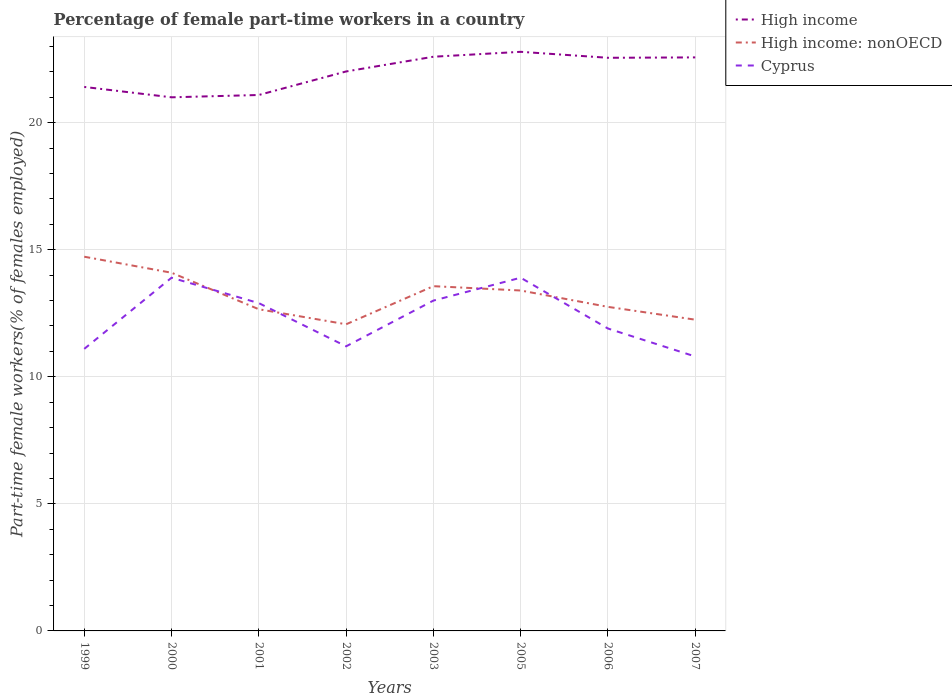Does the line corresponding to Cyprus intersect with the line corresponding to High income: nonOECD?
Your response must be concise. Yes. Across all years, what is the maximum percentage of female part-time workers in Cyprus?
Keep it short and to the point. 10.8. In which year was the percentage of female part-time workers in High income maximum?
Offer a terse response. 2000. What is the total percentage of female part-time workers in Cyprus in the graph?
Make the answer very short. -2.8. What is the difference between the highest and the second highest percentage of female part-time workers in High income?
Make the answer very short. 1.79. What is the difference between the highest and the lowest percentage of female part-time workers in Cyprus?
Keep it short and to the point. 4. Is the percentage of female part-time workers in High income strictly greater than the percentage of female part-time workers in Cyprus over the years?
Offer a terse response. No. How many lines are there?
Ensure brevity in your answer.  3. What is the difference between two consecutive major ticks on the Y-axis?
Provide a succinct answer. 5. Does the graph contain grids?
Your response must be concise. Yes. Where does the legend appear in the graph?
Your answer should be compact. Top right. How many legend labels are there?
Provide a short and direct response. 3. How are the legend labels stacked?
Make the answer very short. Vertical. What is the title of the graph?
Keep it short and to the point. Percentage of female part-time workers in a country. Does "Costa Rica" appear as one of the legend labels in the graph?
Offer a terse response. No. What is the label or title of the X-axis?
Offer a very short reply. Years. What is the label or title of the Y-axis?
Ensure brevity in your answer.  Part-time female workers(% of females employed). What is the Part-time female workers(% of females employed) of High income in 1999?
Provide a short and direct response. 21.41. What is the Part-time female workers(% of females employed) of High income: nonOECD in 1999?
Give a very brief answer. 14.73. What is the Part-time female workers(% of females employed) in Cyprus in 1999?
Your answer should be very brief. 11.1. What is the Part-time female workers(% of females employed) in High income in 2000?
Your answer should be compact. 21. What is the Part-time female workers(% of females employed) of High income: nonOECD in 2000?
Your answer should be very brief. 14.1. What is the Part-time female workers(% of females employed) of Cyprus in 2000?
Your response must be concise. 13.9. What is the Part-time female workers(% of females employed) of High income in 2001?
Offer a terse response. 21.09. What is the Part-time female workers(% of females employed) of High income: nonOECD in 2001?
Offer a terse response. 12.66. What is the Part-time female workers(% of females employed) of Cyprus in 2001?
Offer a terse response. 12.9. What is the Part-time female workers(% of females employed) of High income in 2002?
Offer a terse response. 22.02. What is the Part-time female workers(% of females employed) in High income: nonOECD in 2002?
Your answer should be compact. 12.07. What is the Part-time female workers(% of females employed) in Cyprus in 2002?
Provide a short and direct response. 11.2. What is the Part-time female workers(% of females employed) of High income in 2003?
Your answer should be compact. 22.6. What is the Part-time female workers(% of females employed) in High income: nonOECD in 2003?
Your answer should be very brief. 13.57. What is the Part-time female workers(% of females employed) in High income in 2005?
Provide a succinct answer. 22.79. What is the Part-time female workers(% of females employed) in High income: nonOECD in 2005?
Provide a succinct answer. 13.4. What is the Part-time female workers(% of females employed) in Cyprus in 2005?
Provide a succinct answer. 13.9. What is the Part-time female workers(% of females employed) in High income in 2006?
Offer a terse response. 22.55. What is the Part-time female workers(% of females employed) of High income: nonOECD in 2006?
Provide a short and direct response. 12.75. What is the Part-time female workers(% of females employed) of Cyprus in 2006?
Keep it short and to the point. 11.9. What is the Part-time female workers(% of females employed) in High income in 2007?
Provide a short and direct response. 22.57. What is the Part-time female workers(% of females employed) in High income: nonOECD in 2007?
Your response must be concise. 12.25. What is the Part-time female workers(% of females employed) of Cyprus in 2007?
Your response must be concise. 10.8. Across all years, what is the maximum Part-time female workers(% of females employed) in High income?
Give a very brief answer. 22.79. Across all years, what is the maximum Part-time female workers(% of females employed) of High income: nonOECD?
Keep it short and to the point. 14.73. Across all years, what is the maximum Part-time female workers(% of females employed) of Cyprus?
Offer a terse response. 13.9. Across all years, what is the minimum Part-time female workers(% of females employed) in High income?
Your answer should be compact. 21. Across all years, what is the minimum Part-time female workers(% of females employed) of High income: nonOECD?
Offer a terse response. 12.07. Across all years, what is the minimum Part-time female workers(% of females employed) in Cyprus?
Give a very brief answer. 10.8. What is the total Part-time female workers(% of females employed) of High income in the graph?
Ensure brevity in your answer.  176.03. What is the total Part-time female workers(% of females employed) in High income: nonOECD in the graph?
Your answer should be compact. 105.51. What is the total Part-time female workers(% of females employed) in Cyprus in the graph?
Offer a terse response. 98.7. What is the difference between the Part-time female workers(% of females employed) in High income in 1999 and that in 2000?
Provide a succinct answer. 0.41. What is the difference between the Part-time female workers(% of females employed) in High income: nonOECD in 1999 and that in 2000?
Offer a terse response. 0.63. What is the difference between the Part-time female workers(% of females employed) in Cyprus in 1999 and that in 2000?
Your answer should be very brief. -2.8. What is the difference between the Part-time female workers(% of females employed) in High income in 1999 and that in 2001?
Your answer should be compact. 0.32. What is the difference between the Part-time female workers(% of females employed) of High income: nonOECD in 1999 and that in 2001?
Provide a short and direct response. 2.07. What is the difference between the Part-time female workers(% of females employed) in High income in 1999 and that in 2002?
Keep it short and to the point. -0.61. What is the difference between the Part-time female workers(% of females employed) in High income: nonOECD in 1999 and that in 2002?
Give a very brief answer. 2.66. What is the difference between the Part-time female workers(% of females employed) in High income in 1999 and that in 2003?
Your answer should be very brief. -1.19. What is the difference between the Part-time female workers(% of females employed) in High income: nonOECD in 1999 and that in 2003?
Your answer should be compact. 1.16. What is the difference between the Part-time female workers(% of females employed) in High income in 1999 and that in 2005?
Your answer should be very brief. -1.38. What is the difference between the Part-time female workers(% of females employed) of High income: nonOECD in 1999 and that in 2005?
Give a very brief answer. 1.33. What is the difference between the Part-time female workers(% of females employed) of High income in 1999 and that in 2006?
Offer a terse response. -1.15. What is the difference between the Part-time female workers(% of females employed) of High income: nonOECD in 1999 and that in 2006?
Keep it short and to the point. 1.97. What is the difference between the Part-time female workers(% of females employed) of Cyprus in 1999 and that in 2006?
Give a very brief answer. -0.8. What is the difference between the Part-time female workers(% of females employed) of High income in 1999 and that in 2007?
Ensure brevity in your answer.  -1.16. What is the difference between the Part-time female workers(% of females employed) in High income: nonOECD in 1999 and that in 2007?
Your response must be concise. 2.48. What is the difference between the Part-time female workers(% of females employed) in High income in 2000 and that in 2001?
Your answer should be compact. -0.09. What is the difference between the Part-time female workers(% of females employed) in High income: nonOECD in 2000 and that in 2001?
Keep it short and to the point. 1.44. What is the difference between the Part-time female workers(% of females employed) in High income in 2000 and that in 2002?
Make the answer very short. -1.02. What is the difference between the Part-time female workers(% of females employed) in High income: nonOECD in 2000 and that in 2002?
Your response must be concise. 2.03. What is the difference between the Part-time female workers(% of females employed) in High income in 2000 and that in 2003?
Make the answer very short. -1.6. What is the difference between the Part-time female workers(% of females employed) of High income: nonOECD in 2000 and that in 2003?
Offer a terse response. 0.53. What is the difference between the Part-time female workers(% of females employed) of High income in 2000 and that in 2005?
Your answer should be very brief. -1.79. What is the difference between the Part-time female workers(% of females employed) of High income: nonOECD in 2000 and that in 2005?
Your response must be concise. 0.7. What is the difference between the Part-time female workers(% of females employed) of Cyprus in 2000 and that in 2005?
Make the answer very short. 0. What is the difference between the Part-time female workers(% of females employed) in High income in 2000 and that in 2006?
Offer a very short reply. -1.56. What is the difference between the Part-time female workers(% of females employed) in High income: nonOECD in 2000 and that in 2006?
Make the answer very short. 1.34. What is the difference between the Part-time female workers(% of females employed) of High income in 2000 and that in 2007?
Keep it short and to the point. -1.57. What is the difference between the Part-time female workers(% of females employed) in High income: nonOECD in 2000 and that in 2007?
Your answer should be compact. 1.85. What is the difference between the Part-time female workers(% of females employed) in High income in 2001 and that in 2002?
Provide a succinct answer. -0.93. What is the difference between the Part-time female workers(% of females employed) in High income: nonOECD in 2001 and that in 2002?
Offer a terse response. 0.59. What is the difference between the Part-time female workers(% of females employed) in High income in 2001 and that in 2003?
Ensure brevity in your answer.  -1.51. What is the difference between the Part-time female workers(% of females employed) in High income: nonOECD in 2001 and that in 2003?
Offer a terse response. -0.91. What is the difference between the Part-time female workers(% of females employed) of Cyprus in 2001 and that in 2003?
Make the answer very short. -0.1. What is the difference between the Part-time female workers(% of females employed) of High income in 2001 and that in 2005?
Offer a terse response. -1.7. What is the difference between the Part-time female workers(% of females employed) of High income: nonOECD in 2001 and that in 2005?
Make the answer very short. -0.74. What is the difference between the Part-time female workers(% of females employed) of Cyprus in 2001 and that in 2005?
Make the answer very short. -1. What is the difference between the Part-time female workers(% of females employed) in High income in 2001 and that in 2006?
Your answer should be very brief. -1.46. What is the difference between the Part-time female workers(% of females employed) of High income: nonOECD in 2001 and that in 2006?
Offer a very short reply. -0.09. What is the difference between the Part-time female workers(% of females employed) in High income in 2001 and that in 2007?
Your response must be concise. -1.48. What is the difference between the Part-time female workers(% of females employed) in High income: nonOECD in 2001 and that in 2007?
Provide a succinct answer. 0.41. What is the difference between the Part-time female workers(% of females employed) in High income in 2002 and that in 2003?
Your answer should be very brief. -0.58. What is the difference between the Part-time female workers(% of females employed) in High income: nonOECD in 2002 and that in 2003?
Your response must be concise. -1.5. What is the difference between the Part-time female workers(% of females employed) in Cyprus in 2002 and that in 2003?
Your answer should be compact. -1.8. What is the difference between the Part-time female workers(% of females employed) of High income in 2002 and that in 2005?
Make the answer very short. -0.77. What is the difference between the Part-time female workers(% of females employed) in High income: nonOECD in 2002 and that in 2005?
Your answer should be very brief. -1.33. What is the difference between the Part-time female workers(% of females employed) in High income in 2002 and that in 2006?
Make the answer very short. -0.54. What is the difference between the Part-time female workers(% of females employed) in High income: nonOECD in 2002 and that in 2006?
Give a very brief answer. -0.68. What is the difference between the Part-time female workers(% of females employed) in Cyprus in 2002 and that in 2006?
Provide a short and direct response. -0.7. What is the difference between the Part-time female workers(% of females employed) in High income in 2002 and that in 2007?
Offer a terse response. -0.55. What is the difference between the Part-time female workers(% of females employed) in High income: nonOECD in 2002 and that in 2007?
Provide a succinct answer. -0.18. What is the difference between the Part-time female workers(% of females employed) of High income in 2003 and that in 2005?
Provide a succinct answer. -0.19. What is the difference between the Part-time female workers(% of females employed) in High income: nonOECD in 2003 and that in 2005?
Offer a very short reply. 0.17. What is the difference between the Part-time female workers(% of females employed) of Cyprus in 2003 and that in 2005?
Offer a terse response. -0.9. What is the difference between the Part-time female workers(% of females employed) in High income in 2003 and that in 2006?
Provide a short and direct response. 0.04. What is the difference between the Part-time female workers(% of females employed) in High income: nonOECD in 2003 and that in 2006?
Your response must be concise. 0.81. What is the difference between the Part-time female workers(% of females employed) of High income in 2003 and that in 2007?
Provide a short and direct response. 0.03. What is the difference between the Part-time female workers(% of females employed) in High income: nonOECD in 2003 and that in 2007?
Give a very brief answer. 1.32. What is the difference between the Part-time female workers(% of females employed) in Cyprus in 2003 and that in 2007?
Provide a short and direct response. 2.2. What is the difference between the Part-time female workers(% of females employed) in High income in 2005 and that in 2006?
Offer a terse response. 0.24. What is the difference between the Part-time female workers(% of females employed) in High income: nonOECD in 2005 and that in 2006?
Offer a very short reply. 0.64. What is the difference between the Part-time female workers(% of females employed) of High income in 2005 and that in 2007?
Your answer should be very brief. 0.22. What is the difference between the Part-time female workers(% of females employed) in High income: nonOECD in 2005 and that in 2007?
Give a very brief answer. 1.15. What is the difference between the Part-time female workers(% of females employed) in High income in 2006 and that in 2007?
Offer a terse response. -0.02. What is the difference between the Part-time female workers(% of females employed) in High income: nonOECD in 2006 and that in 2007?
Offer a terse response. 0.5. What is the difference between the Part-time female workers(% of females employed) in High income in 1999 and the Part-time female workers(% of females employed) in High income: nonOECD in 2000?
Provide a short and direct response. 7.31. What is the difference between the Part-time female workers(% of females employed) in High income in 1999 and the Part-time female workers(% of females employed) in Cyprus in 2000?
Your response must be concise. 7.51. What is the difference between the Part-time female workers(% of females employed) of High income: nonOECD in 1999 and the Part-time female workers(% of females employed) of Cyprus in 2000?
Offer a very short reply. 0.83. What is the difference between the Part-time female workers(% of females employed) of High income in 1999 and the Part-time female workers(% of females employed) of High income: nonOECD in 2001?
Ensure brevity in your answer.  8.75. What is the difference between the Part-time female workers(% of females employed) of High income in 1999 and the Part-time female workers(% of females employed) of Cyprus in 2001?
Ensure brevity in your answer.  8.51. What is the difference between the Part-time female workers(% of females employed) of High income: nonOECD in 1999 and the Part-time female workers(% of females employed) of Cyprus in 2001?
Make the answer very short. 1.83. What is the difference between the Part-time female workers(% of females employed) of High income in 1999 and the Part-time female workers(% of females employed) of High income: nonOECD in 2002?
Provide a succinct answer. 9.34. What is the difference between the Part-time female workers(% of females employed) in High income in 1999 and the Part-time female workers(% of females employed) in Cyprus in 2002?
Your answer should be very brief. 10.21. What is the difference between the Part-time female workers(% of females employed) in High income: nonOECD in 1999 and the Part-time female workers(% of females employed) in Cyprus in 2002?
Your response must be concise. 3.53. What is the difference between the Part-time female workers(% of females employed) in High income in 1999 and the Part-time female workers(% of females employed) in High income: nonOECD in 2003?
Your response must be concise. 7.84. What is the difference between the Part-time female workers(% of females employed) in High income in 1999 and the Part-time female workers(% of females employed) in Cyprus in 2003?
Provide a short and direct response. 8.41. What is the difference between the Part-time female workers(% of females employed) in High income: nonOECD in 1999 and the Part-time female workers(% of females employed) in Cyprus in 2003?
Your response must be concise. 1.73. What is the difference between the Part-time female workers(% of females employed) of High income in 1999 and the Part-time female workers(% of females employed) of High income: nonOECD in 2005?
Make the answer very short. 8.01. What is the difference between the Part-time female workers(% of females employed) of High income in 1999 and the Part-time female workers(% of females employed) of Cyprus in 2005?
Your answer should be compact. 7.51. What is the difference between the Part-time female workers(% of females employed) in High income: nonOECD in 1999 and the Part-time female workers(% of females employed) in Cyprus in 2005?
Make the answer very short. 0.83. What is the difference between the Part-time female workers(% of females employed) of High income in 1999 and the Part-time female workers(% of females employed) of High income: nonOECD in 2006?
Keep it short and to the point. 8.66. What is the difference between the Part-time female workers(% of females employed) of High income in 1999 and the Part-time female workers(% of females employed) of Cyprus in 2006?
Your answer should be compact. 9.51. What is the difference between the Part-time female workers(% of females employed) of High income: nonOECD in 1999 and the Part-time female workers(% of females employed) of Cyprus in 2006?
Offer a very short reply. 2.83. What is the difference between the Part-time female workers(% of females employed) in High income in 1999 and the Part-time female workers(% of females employed) in High income: nonOECD in 2007?
Your answer should be compact. 9.16. What is the difference between the Part-time female workers(% of females employed) of High income in 1999 and the Part-time female workers(% of females employed) of Cyprus in 2007?
Give a very brief answer. 10.61. What is the difference between the Part-time female workers(% of females employed) of High income: nonOECD in 1999 and the Part-time female workers(% of females employed) of Cyprus in 2007?
Ensure brevity in your answer.  3.93. What is the difference between the Part-time female workers(% of females employed) of High income in 2000 and the Part-time female workers(% of females employed) of High income: nonOECD in 2001?
Keep it short and to the point. 8.34. What is the difference between the Part-time female workers(% of females employed) of High income in 2000 and the Part-time female workers(% of females employed) of Cyprus in 2001?
Provide a succinct answer. 8.1. What is the difference between the Part-time female workers(% of females employed) in High income: nonOECD in 2000 and the Part-time female workers(% of females employed) in Cyprus in 2001?
Ensure brevity in your answer.  1.2. What is the difference between the Part-time female workers(% of females employed) of High income in 2000 and the Part-time female workers(% of females employed) of High income: nonOECD in 2002?
Make the answer very short. 8.93. What is the difference between the Part-time female workers(% of females employed) of High income in 2000 and the Part-time female workers(% of females employed) of Cyprus in 2002?
Provide a short and direct response. 9.8. What is the difference between the Part-time female workers(% of females employed) in High income: nonOECD in 2000 and the Part-time female workers(% of females employed) in Cyprus in 2002?
Provide a short and direct response. 2.9. What is the difference between the Part-time female workers(% of females employed) in High income in 2000 and the Part-time female workers(% of females employed) in High income: nonOECD in 2003?
Make the answer very short. 7.43. What is the difference between the Part-time female workers(% of females employed) in High income in 2000 and the Part-time female workers(% of females employed) in Cyprus in 2003?
Your response must be concise. 8. What is the difference between the Part-time female workers(% of females employed) in High income: nonOECD in 2000 and the Part-time female workers(% of females employed) in Cyprus in 2003?
Provide a succinct answer. 1.1. What is the difference between the Part-time female workers(% of females employed) of High income in 2000 and the Part-time female workers(% of females employed) of High income: nonOECD in 2005?
Provide a succinct answer. 7.6. What is the difference between the Part-time female workers(% of females employed) in High income in 2000 and the Part-time female workers(% of females employed) in Cyprus in 2005?
Your answer should be compact. 7.1. What is the difference between the Part-time female workers(% of females employed) in High income: nonOECD in 2000 and the Part-time female workers(% of females employed) in Cyprus in 2005?
Make the answer very short. 0.2. What is the difference between the Part-time female workers(% of females employed) of High income in 2000 and the Part-time female workers(% of females employed) of High income: nonOECD in 2006?
Offer a terse response. 8.25. What is the difference between the Part-time female workers(% of females employed) in High income in 2000 and the Part-time female workers(% of females employed) in Cyprus in 2006?
Your response must be concise. 9.1. What is the difference between the Part-time female workers(% of females employed) in High income: nonOECD in 2000 and the Part-time female workers(% of females employed) in Cyprus in 2006?
Keep it short and to the point. 2.2. What is the difference between the Part-time female workers(% of females employed) in High income in 2000 and the Part-time female workers(% of females employed) in High income: nonOECD in 2007?
Your answer should be compact. 8.75. What is the difference between the Part-time female workers(% of females employed) in High income in 2000 and the Part-time female workers(% of females employed) in Cyprus in 2007?
Your answer should be compact. 10.2. What is the difference between the Part-time female workers(% of females employed) in High income: nonOECD in 2000 and the Part-time female workers(% of females employed) in Cyprus in 2007?
Make the answer very short. 3.3. What is the difference between the Part-time female workers(% of females employed) of High income in 2001 and the Part-time female workers(% of females employed) of High income: nonOECD in 2002?
Ensure brevity in your answer.  9.02. What is the difference between the Part-time female workers(% of females employed) in High income in 2001 and the Part-time female workers(% of females employed) in Cyprus in 2002?
Your answer should be compact. 9.89. What is the difference between the Part-time female workers(% of females employed) of High income: nonOECD in 2001 and the Part-time female workers(% of females employed) of Cyprus in 2002?
Keep it short and to the point. 1.46. What is the difference between the Part-time female workers(% of females employed) of High income in 2001 and the Part-time female workers(% of females employed) of High income: nonOECD in 2003?
Offer a terse response. 7.52. What is the difference between the Part-time female workers(% of females employed) of High income in 2001 and the Part-time female workers(% of females employed) of Cyprus in 2003?
Ensure brevity in your answer.  8.09. What is the difference between the Part-time female workers(% of females employed) in High income: nonOECD in 2001 and the Part-time female workers(% of females employed) in Cyprus in 2003?
Your response must be concise. -0.34. What is the difference between the Part-time female workers(% of females employed) in High income in 2001 and the Part-time female workers(% of females employed) in High income: nonOECD in 2005?
Your response must be concise. 7.69. What is the difference between the Part-time female workers(% of females employed) of High income in 2001 and the Part-time female workers(% of females employed) of Cyprus in 2005?
Make the answer very short. 7.19. What is the difference between the Part-time female workers(% of females employed) in High income: nonOECD in 2001 and the Part-time female workers(% of females employed) in Cyprus in 2005?
Ensure brevity in your answer.  -1.24. What is the difference between the Part-time female workers(% of females employed) in High income in 2001 and the Part-time female workers(% of females employed) in High income: nonOECD in 2006?
Ensure brevity in your answer.  8.34. What is the difference between the Part-time female workers(% of females employed) in High income in 2001 and the Part-time female workers(% of females employed) in Cyprus in 2006?
Offer a terse response. 9.19. What is the difference between the Part-time female workers(% of females employed) of High income: nonOECD in 2001 and the Part-time female workers(% of females employed) of Cyprus in 2006?
Ensure brevity in your answer.  0.76. What is the difference between the Part-time female workers(% of females employed) in High income in 2001 and the Part-time female workers(% of females employed) in High income: nonOECD in 2007?
Make the answer very short. 8.84. What is the difference between the Part-time female workers(% of females employed) of High income in 2001 and the Part-time female workers(% of females employed) of Cyprus in 2007?
Your answer should be very brief. 10.29. What is the difference between the Part-time female workers(% of females employed) in High income: nonOECD in 2001 and the Part-time female workers(% of females employed) in Cyprus in 2007?
Offer a very short reply. 1.86. What is the difference between the Part-time female workers(% of females employed) in High income in 2002 and the Part-time female workers(% of females employed) in High income: nonOECD in 2003?
Offer a terse response. 8.45. What is the difference between the Part-time female workers(% of females employed) in High income in 2002 and the Part-time female workers(% of females employed) in Cyprus in 2003?
Give a very brief answer. 9.02. What is the difference between the Part-time female workers(% of females employed) of High income: nonOECD in 2002 and the Part-time female workers(% of females employed) of Cyprus in 2003?
Give a very brief answer. -0.93. What is the difference between the Part-time female workers(% of females employed) in High income in 2002 and the Part-time female workers(% of females employed) in High income: nonOECD in 2005?
Offer a terse response. 8.62. What is the difference between the Part-time female workers(% of females employed) in High income in 2002 and the Part-time female workers(% of females employed) in Cyprus in 2005?
Your answer should be very brief. 8.12. What is the difference between the Part-time female workers(% of females employed) in High income: nonOECD in 2002 and the Part-time female workers(% of females employed) in Cyprus in 2005?
Make the answer very short. -1.83. What is the difference between the Part-time female workers(% of females employed) in High income in 2002 and the Part-time female workers(% of females employed) in High income: nonOECD in 2006?
Your answer should be very brief. 9.26. What is the difference between the Part-time female workers(% of females employed) in High income in 2002 and the Part-time female workers(% of females employed) in Cyprus in 2006?
Provide a succinct answer. 10.12. What is the difference between the Part-time female workers(% of females employed) of High income: nonOECD in 2002 and the Part-time female workers(% of females employed) of Cyprus in 2006?
Provide a succinct answer. 0.17. What is the difference between the Part-time female workers(% of females employed) in High income in 2002 and the Part-time female workers(% of females employed) in High income: nonOECD in 2007?
Ensure brevity in your answer.  9.77. What is the difference between the Part-time female workers(% of females employed) in High income in 2002 and the Part-time female workers(% of females employed) in Cyprus in 2007?
Provide a short and direct response. 11.22. What is the difference between the Part-time female workers(% of females employed) of High income: nonOECD in 2002 and the Part-time female workers(% of females employed) of Cyprus in 2007?
Your answer should be compact. 1.27. What is the difference between the Part-time female workers(% of females employed) in High income in 2003 and the Part-time female workers(% of females employed) in High income: nonOECD in 2005?
Offer a very short reply. 9.2. What is the difference between the Part-time female workers(% of females employed) in High income in 2003 and the Part-time female workers(% of females employed) in Cyprus in 2005?
Make the answer very short. 8.7. What is the difference between the Part-time female workers(% of females employed) of High income: nonOECD in 2003 and the Part-time female workers(% of females employed) of Cyprus in 2005?
Offer a very short reply. -0.33. What is the difference between the Part-time female workers(% of females employed) in High income in 2003 and the Part-time female workers(% of females employed) in High income: nonOECD in 2006?
Keep it short and to the point. 9.84. What is the difference between the Part-time female workers(% of females employed) in High income in 2003 and the Part-time female workers(% of females employed) in Cyprus in 2006?
Offer a terse response. 10.7. What is the difference between the Part-time female workers(% of females employed) of High income: nonOECD in 2003 and the Part-time female workers(% of females employed) of Cyprus in 2006?
Provide a succinct answer. 1.67. What is the difference between the Part-time female workers(% of females employed) of High income in 2003 and the Part-time female workers(% of females employed) of High income: nonOECD in 2007?
Your answer should be very brief. 10.35. What is the difference between the Part-time female workers(% of females employed) in High income in 2003 and the Part-time female workers(% of females employed) in Cyprus in 2007?
Ensure brevity in your answer.  11.8. What is the difference between the Part-time female workers(% of females employed) in High income: nonOECD in 2003 and the Part-time female workers(% of females employed) in Cyprus in 2007?
Your answer should be compact. 2.77. What is the difference between the Part-time female workers(% of females employed) of High income in 2005 and the Part-time female workers(% of females employed) of High income: nonOECD in 2006?
Provide a succinct answer. 10.04. What is the difference between the Part-time female workers(% of females employed) in High income in 2005 and the Part-time female workers(% of females employed) in Cyprus in 2006?
Offer a very short reply. 10.89. What is the difference between the Part-time female workers(% of females employed) in High income: nonOECD in 2005 and the Part-time female workers(% of females employed) in Cyprus in 2006?
Offer a terse response. 1.5. What is the difference between the Part-time female workers(% of females employed) of High income in 2005 and the Part-time female workers(% of females employed) of High income: nonOECD in 2007?
Give a very brief answer. 10.54. What is the difference between the Part-time female workers(% of females employed) in High income in 2005 and the Part-time female workers(% of females employed) in Cyprus in 2007?
Offer a very short reply. 11.99. What is the difference between the Part-time female workers(% of females employed) in High income: nonOECD in 2005 and the Part-time female workers(% of females employed) in Cyprus in 2007?
Offer a very short reply. 2.6. What is the difference between the Part-time female workers(% of females employed) of High income in 2006 and the Part-time female workers(% of females employed) of High income: nonOECD in 2007?
Make the answer very short. 10.31. What is the difference between the Part-time female workers(% of females employed) in High income in 2006 and the Part-time female workers(% of females employed) in Cyprus in 2007?
Keep it short and to the point. 11.75. What is the difference between the Part-time female workers(% of females employed) in High income: nonOECD in 2006 and the Part-time female workers(% of females employed) in Cyprus in 2007?
Give a very brief answer. 1.95. What is the average Part-time female workers(% of females employed) in High income per year?
Offer a terse response. 22. What is the average Part-time female workers(% of females employed) of High income: nonOECD per year?
Ensure brevity in your answer.  13.19. What is the average Part-time female workers(% of females employed) in Cyprus per year?
Offer a terse response. 12.34. In the year 1999, what is the difference between the Part-time female workers(% of females employed) in High income and Part-time female workers(% of females employed) in High income: nonOECD?
Make the answer very short. 6.68. In the year 1999, what is the difference between the Part-time female workers(% of females employed) in High income and Part-time female workers(% of females employed) in Cyprus?
Provide a short and direct response. 10.31. In the year 1999, what is the difference between the Part-time female workers(% of females employed) of High income: nonOECD and Part-time female workers(% of females employed) of Cyprus?
Ensure brevity in your answer.  3.63. In the year 2000, what is the difference between the Part-time female workers(% of females employed) of High income and Part-time female workers(% of females employed) of High income: nonOECD?
Offer a terse response. 6.9. In the year 2000, what is the difference between the Part-time female workers(% of females employed) in High income and Part-time female workers(% of females employed) in Cyprus?
Offer a very short reply. 7.1. In the year 2000, what is the difference between the Part-time female workers(% of females employed) of High income: nonOECD and Part-time female workers(% of females employed) of Cyprus?
Provide a short and direct response. 0.2. In the year 2001, what is the difference between the Part-time female workers(% of females employed) of High income and Part-time female workers(% of females employed) of High income: nonOECD?
Your response must be concise. 8.43. In the year 2001, what is the difference between the Part-time female workers(% of females employed) of High income and Part-time female workers(% of females employed) of Cyprus?
Offer a very short reply. 8.19. In the year 2001, what is the difference between the Part-time female workers(% of females employed) in High income: nonOECD and Part-time female workers(% of females employed) in Cyprus?
Your response must be concise. -0.24. In the year 2002, what is the difference between the Part-time female workers(% of females employed) of High income and Part-time female workers(% of females employed) of High income: nonOECD?
Offer a terse response. 9.95. In the year 2002, what is the difference between the Part-time female workers(% of females employed) of High income and Part-time female workers(% of females employed) of Cyprus?
Provide a succinct answer. 10.82. In the year 2002, what is the difference between the Part-time female workers(% of females employed) in High income: nonOECD and Part-time female workers(% of females employed) in Cyprus?
Offer a terse response. 0.87. In the year 2003, what is the difference between the Part-time female workers(% of females employed) in High income and Part-time female workers(% of females employed) in High income: nonOECD?
Keep it short and to the point. 9.03. In the year 2003, what is the difference between the Part-time female workers(% of females employed) in High income and Part-time female workers(% of females employed) in Cyprus?
Make the answer very short. 9.6. In the year 2003, what is the difference between the Part-time female workers(% of females employed) in High income: nonOECD and Part-time female workers(% of females employed) in Cyprus?
Ensure brevity in your answer.  0.57. In the year 2005, what is the difference between the Part-time female workers(% of females employed) of High income and Part-time female workers(% of females employed) of High income: nonOECD?
Your answer should be very brief. 9.39. In the year 2005, what is the difference between the Part-time female workers(% of females employed) of High income and Part-time female workers(% of females employed) of Cyprus?
Ensure brevity in your answer.  8.89. In the year 2005, what is the difference between the Part-time female workers(% of females employed) of High income: nonOECD and Part-time female workers(% of females employed) of Cyprus?
Provide a short and direct response. -0.5. In the year 2006, what is the difference between the Part-time female workers(% of females employed) of High income and Part-time female workers(% of females employed) of High income: nonOECD?
Your answer should be compact. 9.8. In the year 2006, what is the difference between the Part-time female workers(% of females employed) in High income and Part-time female workers(% of females employed) in Cyprus?
Make the answer very short. 10.65. In the year 2006, what is the difference between the Part-time female workers(% of females employed) in High income: nonOECD and Part-time female workers(% of females employed) in Cyprus?
Give a very brief answer. 0.85. In the year 2007, what is the difference between the Part-time female workers(% of females employed) of High income and Part-time female workers(% of females employed) of High income: nonOECD?
Your response must be concise. 10.32. In the year 2007, what is the difference between the Part-time female workers(% of females employed) of High income and Part-time female workers(% of females employed) of Cyprus?
Provide a short and direct response. 11.77. In the year 2007, what is the difference between the Part-time female workers(% of females employed) in High income: nonOECD and Part-time female workers(% of females employed) in Cyprus?
Make the answer very short. 1.45. What is the ratio of the Part-time female workers(% of females employed) in High income in 1999 to that in 2000?
Your answer should be very brief. 1.02. What is the ratio of the Part-time female workers(% of females employed) in High income: nonOECD in 1999 to that in 2000?
Offer a terse response. 1.04. What is the ratio of the Part-time female workers(% of females employed) of Cyprus in 1999 to that in 2000?
Provide a short and direct response. 0.8. What is the ratio of the Part-time female workers(% of females employed) of High income: nonOECD in 1999 to that in 2001?
Offer a terse response. 1.16. What is the ratio of the Part-time female workers(% of females employed) of Cyprus in 1999 to that in 2001?
Offer a terse response. 0.86. What is the ratio of the Part-time female workers(% of females employed) of High income in 1999 to that in 2002?
Your answer should be very brief. 0.97. What is the ratio of the Part-time female workers(% of females employed) in High income: nonOECD in 1999 to that in 2002?
Your answer should be compact. 1.22. What is the ratio of the Part-time female workers(% of females employed) in High income in 1999 to that in 2003?
Offer a terse response. 0.95. What is the ratio of the Part-time female workers(% of females employed) of High income: nonOECD in 1999 to that in 2003?
Your response must be concise. 1.09. What is the ratio of the Part-time female workers(% of females employed) in Cyprus in 1999 to that in 2003?
Give a very brief answer. 0.85. What is the ratio of the Part-time female workers(% of females employed) in High income in 1999 to that in 2005?
Provide a short and direct response. 0.94. What is the ratio of the Part-time female workers(% of females employed) of High income: nonOECD in 1999 to that in 2005?
Make the answer very short. 1.1. What is the ratio of the Part-time female workers(% of females employed) in Cyprus in 1999 to that in 2005?
Ensure brevity in your answer.  0.8. What is the ratio of the Part-time female workers(% of females employed) of High income in 1999 to that in 2006?
Keep it short and to the point. 0.95. What is the ratio of the Part-time female workers(% of females employed) of High income: nonOECD in 1999 to that in 2006?
Provide a short and direct response. 1.15. What is the ratio of the Part-time female workers(% of females employed) of Cyprus in 1999 to that in 2006?
Offer a very short reply. 0.93. What is the ratio of the Part-time female workers(% of females employed) of High income in 1999 to that in 2007?
Offer a very short reply. 0.95. What is the ratio of the Part-time female workers(% of females employed) in High income: nonOECD in 1999 to that in 2007?
Your answer should be very brief. 1.2. What is the ratio of the Part-time female workers(% of females employed) in Cyprus in 1999 to that in 2007?
Ensure brevity in your answer.  1.03. What is the ratio of the Part-time female workers(% of females employed) of High income: nonOECD in 2000 to that in 2001?
Ensure brevity in your answer.  1.11. What is the ratio of the Part-time female workers(% of females employed) in Cyprus in 2000 to that in 2001?
Ensure brevity in your answer.  1.08. What is the ratio of the Part-time female workers(% of females employed) of High income in 2000 to that in 2002?
Make the answer very short. 0.95. What is the ratio of the Part-time female workers(% of females employed) in High income: nonOECD in 2000 to that in 2002?
Offer a terse response. 1.17. What is the ratio of the Part-time female workers(% of females employed) in Cyprus in 2000 to that in 2002?
Your answer should be very brief. 1.24. What is the ratio of the Part-time female workers(% of females employed) of High income in 2000 to that in 2003?
Your answer should be very brief. 0.93. What is the ratio of the Part-time female workers(% of females employed) of High income: nonOECD in 2000 to that in 2003?
Your response must be concise. 1.04. What is the ratio of the Part-time female workers(% of females employed) of Cyprus in 2000 to that in 2003?
Keep it short and to the point. 1.07. What is the ratio of the Part-time female workers(% of females employed) of High income in 2000 to that in 2005?
Offer a very short reply. 0.92. What is the ratio of the Part-time female workers(% of females employed) of High income: nonOECD in 2000 to that in 2005?
Offer a very short reply. 1.05. What is the ratio of the Part-time female workers(% of females employed) in High income in 2000 to that in 2006?
Give a very brief answer. 0.93. What is the ratio of the Part-time female workers(% of females employed) of High income: nonOECD in 2000 to that in 2006?
Keep it short and to the point. 1.11. What is the ratio of the Part-time female workers(% of females employed) in Cyprus in 2000 to that in 2006?
Provide a short and direct response. 1.17. What is the ratio of the Part-time female workers(% of females employed) of High income in 2000 to that in 2007?
Ensure brevity in your answer.  0.93. What is the ratio of the Part-time female workers(% of females employed) in High income: nonOECD in 2000 to that in 2007?
Offer a very short reply. 1.15. What is the ratio of the Part-time female workers(% of females employed) of Cyprus in 2000 to that in 2007?
Your answer should be very brief. 1.29. What is the ratio of the Part-time female workers(% of females employed) in High income in 2001 to that in 2002?
Offer a very short reply. 0.96. What is the ratio of the Part-time female workers(% of females employed) in High income: nonOECD in 2001 to that in 2002?
Provide a succinct answer. 1.05. What is the ratio of the Part-time female workers(% of females employed) of Cyprus in 2001 to that in 2002?
Offer a very short reply. 1.15. What is the ratio of the Part-time female workers(% of females employed) of High income in 2001 to that in 2003?
Your answer should be very brief. 0.93. What is the ratio of the Part-time female workers(% of females employed) of High income: nonOECD in 2001 to that in 2003?
Ensure brevity in your answer.  0.93. What is the ratio of the Part-time female workers(% of females employed) of Cyprus in 2001 to that in 2003?
Your answer should be compact. 0.99. What is the ratio of the Part-time female workers(% of females employed) in High income in 2001 to that in 2005?
Offer a very short reply. 0.93. What is the ratio of the Part-time female workers(% of females employed) of High income: nonOECD in 2001 to that in 2005?
Your answer should be very brief. 0.94. What is the ratio of the Part-time female workers(% of females employed) in Cyprus in 2001 to that in 2005?
Your answer should be compact. 0.93. What is the ratio of the Part-time female workers(% of females employed) of High income in 2001 to that in 2006?
Provide a succinct answer. 0.94. What is the ratio of the Part-time female workers(% of females employed) in High income: nonOECD in 2001 to that in 2006?
Provide a short and direct response. 0.99. What is the ratio of the Part-time female workers(% of females employed) of Cyprus in 2001 to that in 2006?
Your response must be concise. 1.08. What is the ratio of the Part-time female workers(% of females employed) in High income in 2001 to that in 2007?
Your answer should be very brief. 0.93. What is the ratio of the Part-time female workers(% of females employed) of High income: nonOECD in 2001 to that in 2007?
Provide a short and direct response. 1.03. What is the ratio of the Part-time female workers(% of females employed) in Cyprus in 2001 to that in 2007?
Provide a succinct answer. 1.19. What is the ratio of the Part-time female workers(% of females employed) of High income in 2002 to that in 2003?
Offer a terse response. 0.97. What is the ratio of the Part-time female workers(% of females employed) of High income: nonOECD in 2002 to that in 2003?
Give a very brief answer. 0.89. What is the ratio of the Part-time female workers(% of females employed) of Cyprus in 2002 to that in 2003?
Provide a short and direct response. 0.86. What is the ratio of the Part-time female workers(% of females employed) in High income in 2002 to that in 2005?
Offer a very short reply. 0.97. What is the ratio of the Part-time female workers(% of females employed) of High income: nonOECD in 2002 to that in 2005?
Your answer should be very brief. 0.9. What is the ratio of the Part-time female workers(% of females employed) of Cyprus in 2002 to that in 2005?
Give a very brief answer. 0.81. What is the ratio of the Part-time female workers(% of females employed) of High income in 2002 to that in 2006?
Provide a short and direct response. 0.98. What is the ratio of the Part-time female workers(% of females employed) of High income: nonOECD in 2002 to that in 2006?
Offer a terse response. 0.95. What is the ratio of the Part-time female workers(% of females employed) in Cyprus in 2002 to that in 2006?
Give a very brief answer. 0.94. What is the ratio of the Part-time female workers(% of females employed) of High income in 2002 to that in 2007?
Your response must be concise. 0.98. What is the ratio of the Part-time female workers(% of females employed) of High income: nonOECD in 2002 to that in 2007?
Your answer should be very brief. 0.99. What is the ratio of the Part-time female workers(% of females employed) of Cyprus in 2002 to that in 2007?
Your answer should be very brief. 1.04. What is the ratio of the Part-time female workers(% of females employed) of High income in 2003 to that in 2005?
Offer a terse response. 0.99. What is the ratio of the Part-time female workers(% of females employed) of High income: nonOECD in 2003 to that in 2005?
Offer a very short reply. 1.01. What is the ratio of the Part-time female workers(% of females employed) of Cyprus in 2003 to that in 2005?
Your answer should be very brief. 0.94. What is the ratio of the Part-time female workers(% of females employed) in High income: nonOECD in 2003 to that in 2006?
Give a very brief answer. 1.06. What is the ratio of the Part-time female workers(% of females employed) in Cyprus in 2003 to that in 2006?
Your answer should be very brief. 1.09. What is the ratio of the Part-time female workers(% of females employed) in High income in 2003 to that in 2007?
Make the answer very short. 1. What is the ratio of the Part-time female workers(% of females employed) of High income: nonOECD in 2003 to that in 2007?
Your answer should be very brief. 1.11. What is the ratio of the Part-time female workers(% of females employed) in Cyprus in 2003 to that in 2007?
Your response must be concise. 1.2. What is the ratio of the Part-time female workers(% of females employed) in High income in 2005 to that in 2006?
Your answer should be very brief. 1.01. What is the ratio of the Part-time female workers(% of females employed) of High income: nonOECD in 2005 to that in 2006?
Your response must be concise. 1.05. What is the ratio of the Part-time female workers(% of females employed) in Cyprus in 2005 to that in 2006?
Give a very brief answer. 1.17. What is the ratio of the Part-time female workers(% of females employed) in High income in 2005 to that in 2007?
Your response must be concise. 1.01. What is the ratio of the Part-time female workers(% of females employed) in High income: nonOECD in 2005 to that in 2007?
Your response must be concise. 1.09. What is the ratio of the Part-time female workers(% of females employed) of Cyprus in 2005 to that in 2007?
Your answer should be compact. 1.29. What is the ratio of the Part-time female workers(% of females employed) of High income in 2006 to that in 2007?
Ensure brevity in your answer.  1. What is the ratio of the Part-time female workers(% of females employed) of High income: nonOECD in 2006 to that in 2007?
Provide a short and direct response. 1.04. What is the ratio of the Part-time female workers(% of females employed) of Cyprus in 2006 to that in 2007?
Ensure brevity in your answer.  1.1. What is the difference between the highest and the second highest Part-time female workers(% of females employed) of High income?
Offer a very short reply. 0.19. What is the difference between the highest and the second highest Part-time female workers(% of females employed) in High income: nonOECD?
Keep it short and to the point. 0.63. What is the difference between the highest and the second highest Part-time female workers(% of females employed) of Cyprus?
Your answer should be very brief. 0. What is the difference between the highest and the lowest Part-time female workers(% of females employed) in High income?
Give a very brief answer. 1.79. What is the difference between the highest and the lowest Part-time female workers(% of females employed) in High income: nonOECD?
Keep it short and to the point. 2.66. What is the difference between the highest and the lowest Part-time female workers(% of females employed) in Cyprus?
Offer a very short reply. 3.1. 